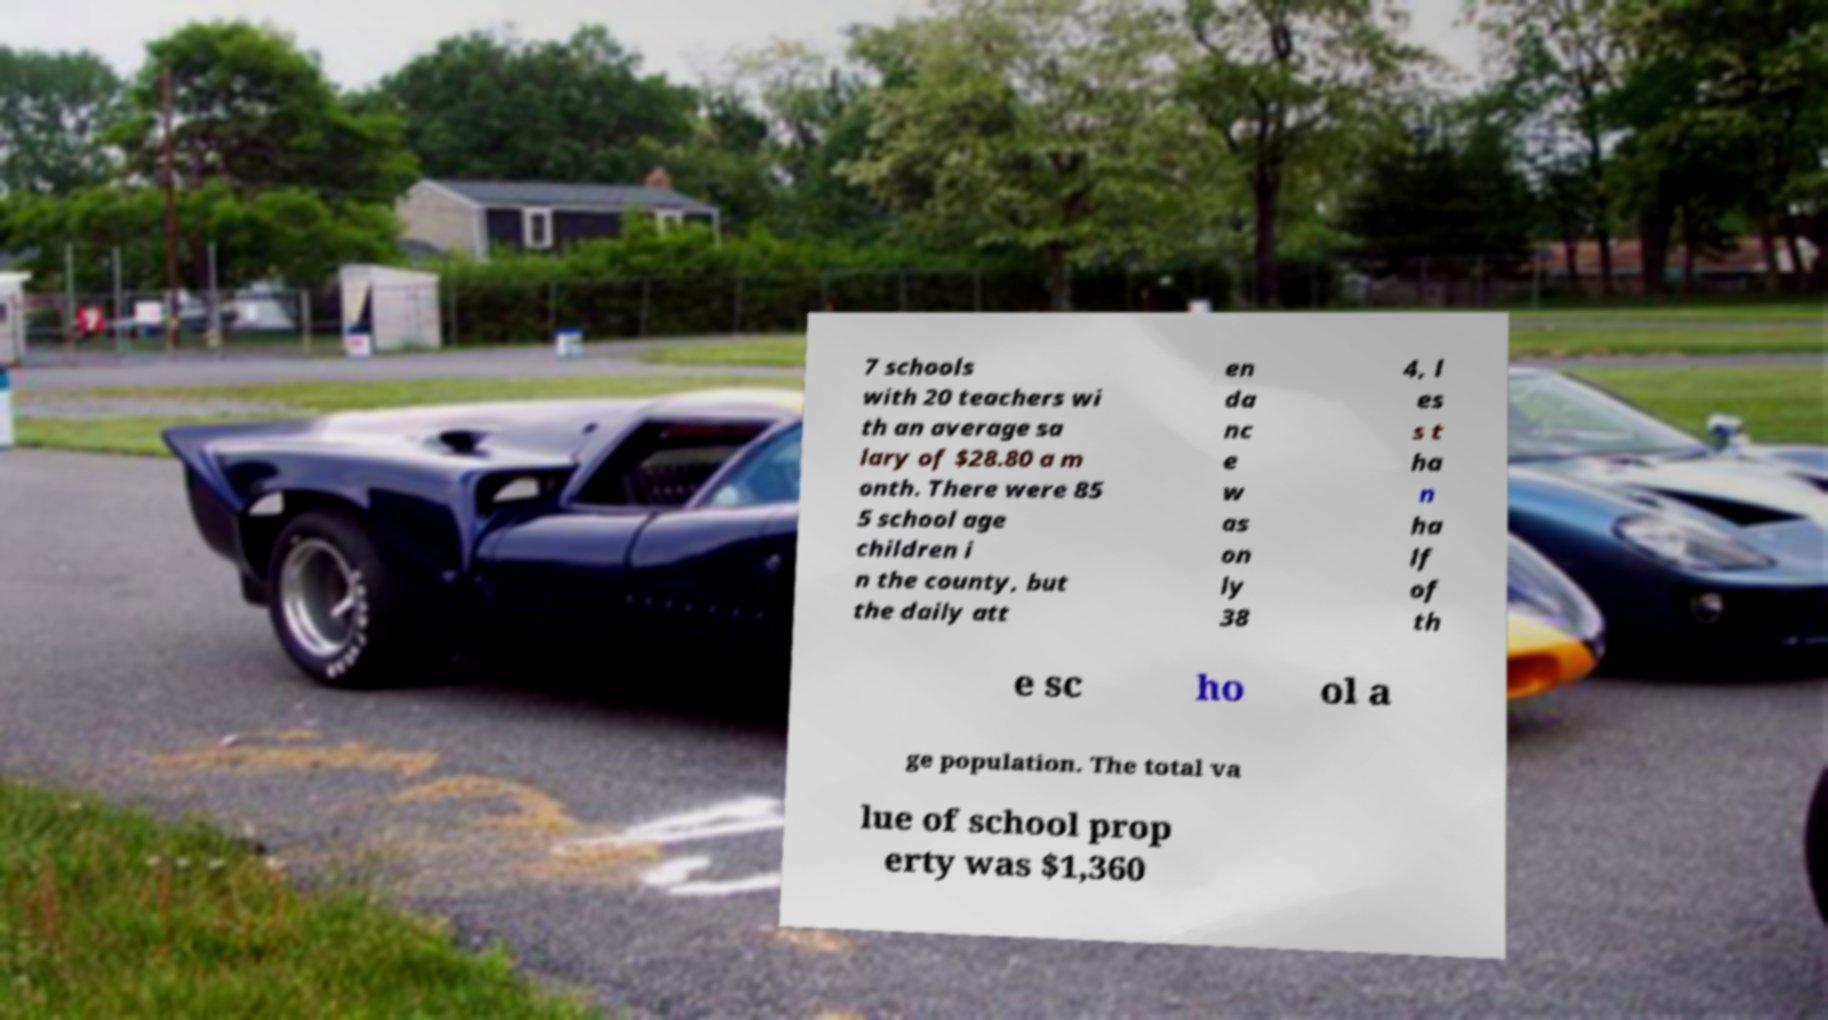Please read and relay the text visible in this image. What does it say? 7 schools with 20 teachers wi th an average sa lary of $28.80 a m onth. There were 85 5 school age children i n the county, but the daily att en da nc e w as on ly 38 4, l es s t ha n ha lf of th e sc ho ol a ge population. The total va lue of school prop erty was $1,360 